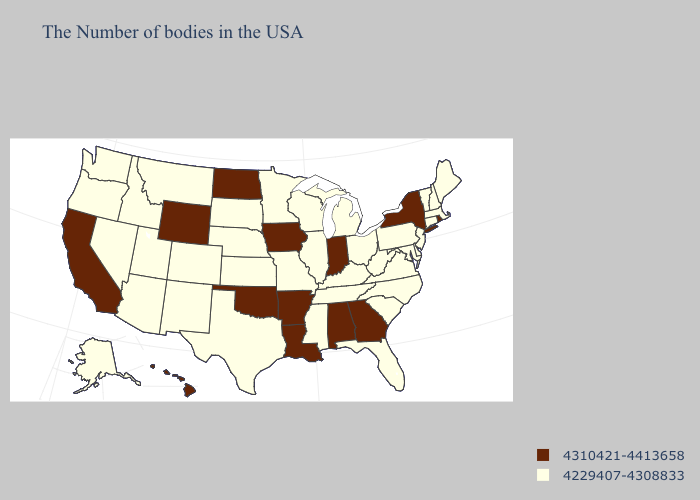Does Missouri have a higher value than West Virginia?
Short answer required. No. Does Alaska have the highest value in the USA?
Be succinct. No. Does Louisiana have the lowest value in the South?
Short answer required. No. Among the states that border Massachusetts , which have the lowest value?
Be succinct. New Hampshire, Vermont, Connecticut. What is the value of Iowa?
Answer briefly. 4310421-4413658. Among the states that border Tennessee , does Mississippi have the lowest value?
Give a very brief answer. Yes. Name the states that have a value in the range 4310421-4413658?
Concise answer only. Rhode Island, New York, Georgia, Indiana, Alabama, Louisiana, Arkansas, Iowa, Oklahoma, North Dakota, Wyoming, California, Hawaii. Name the states that have a value in the range 4310421-4413658?
Concise answer only. Rhode Island, New York, Georgia, Indiana, Alabama, Louisiana, Arkansas, Iowa, Oklahoma, North Dakota, Wyoming, California, Hawaii. Does Tennessee have the lowest value in the South?
Keep it brief. Yes. What is the value of North Carolina?
Concise answer only. 4229407-4308833. Is the legend a continuous bar?
Quick response, please. No. What is the highest value in the South ?
Short answer required. 4310421-4413658. What is the value of Michigan?
Write a very short answer. 4229407-4308833. What is the highest value in the USA?
Give a very brief answer. 4310421-4413658. Name the states that have a value in the range 4229407-4308833?
Concise answer only. Maine, Massachusetts, New Hampshire, Vermont, Connecticut, New Jersey, Delaware, Maryland, Pennsylvania, Virginia, North Carolina, South Carolina, West Virginia, Ohio, Florida, Michigan, Kentucky, Tennessee, Wisconsin, Illinois, Mississippi, Missouri, Minnesota, Kansas, Nebraska, Texas, South Dakota, Colorado, New Mexico, Utah, Montana, Arizona, Idaho, Nevada, Washington, Oregon, Alaska. 